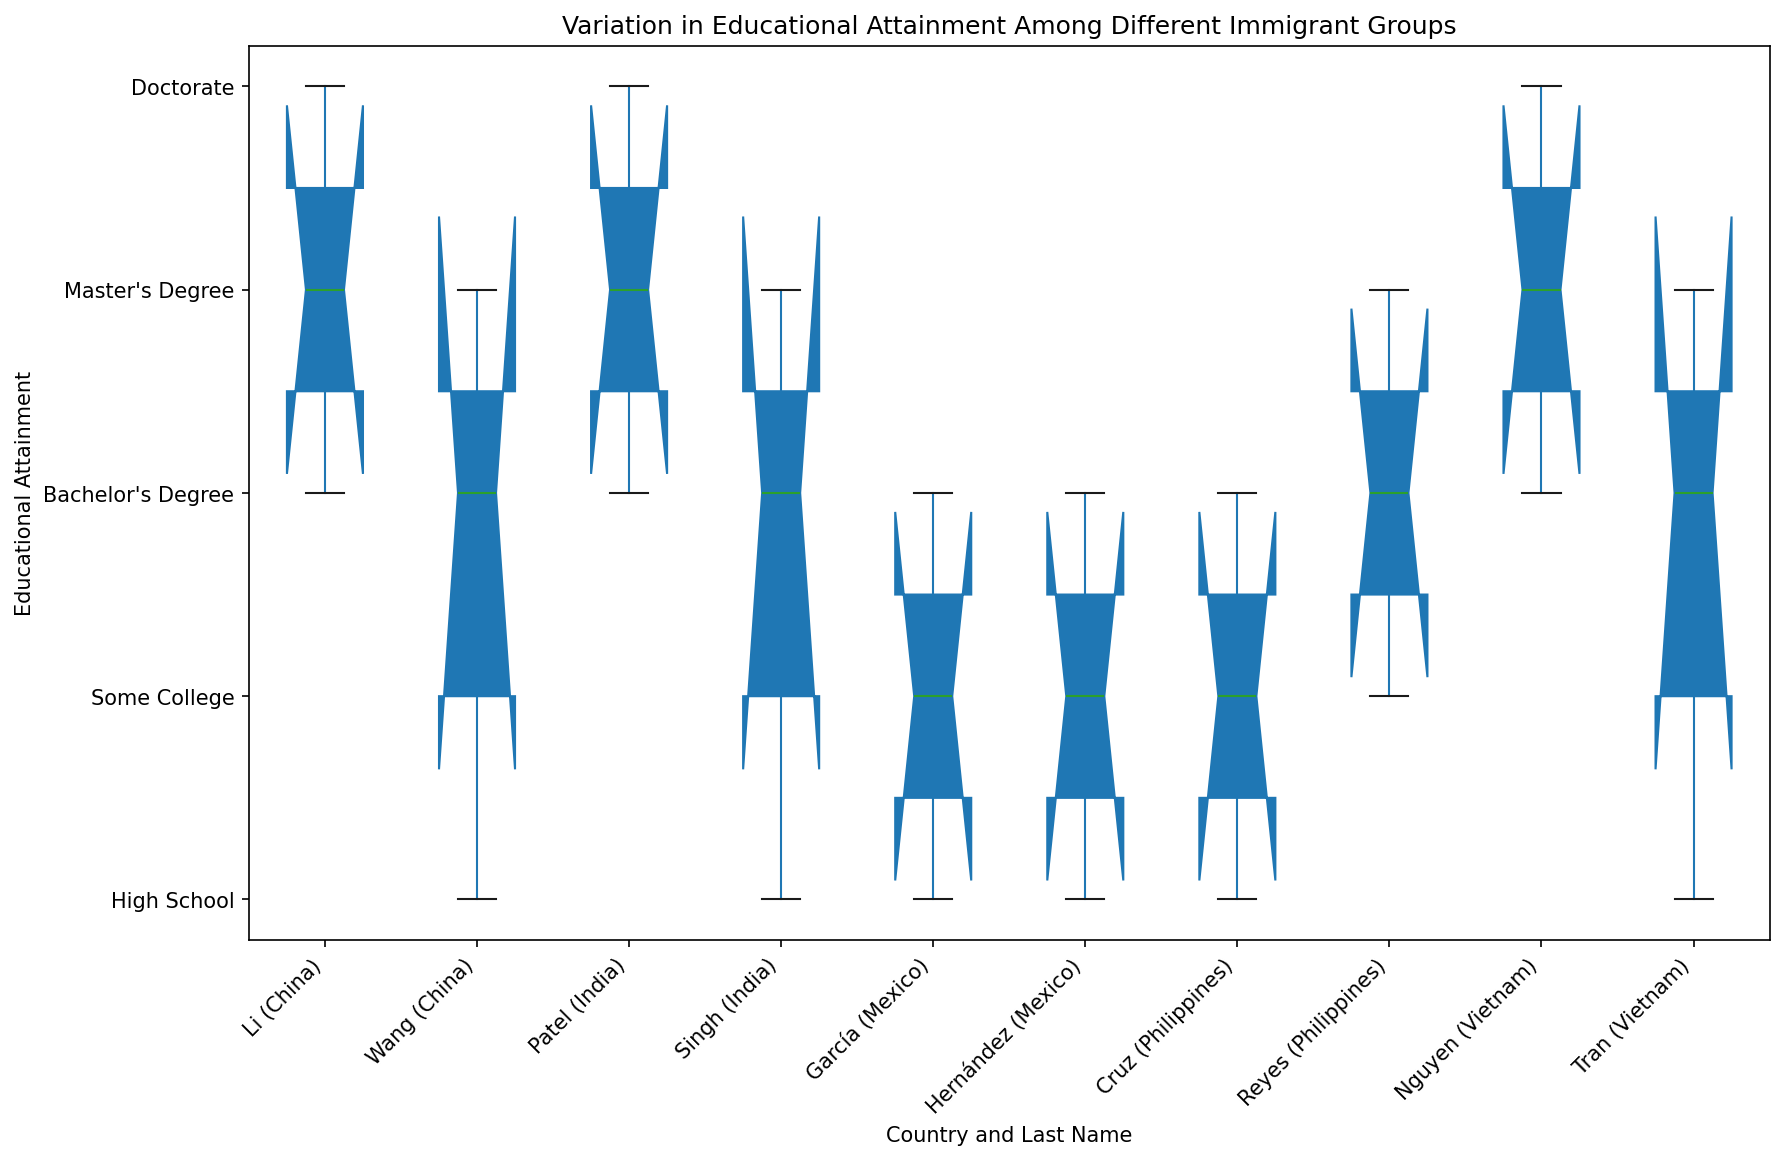Which group has the highest median educational attainment? To find which group has the highest median educational attainment, locate the central mark (median line) within each box of the plot. The Nguyen (Vietnam) group, having a median represented by the line at "Master's Degree" (3), has the highest median educational attainment.
Answer: Nguyen (Vietnam) Between the groups from India, which has greater variation in educational attainment levels: Patel or Singh? Variation can be observed by the height of the boxes and the lengths of the whiskers. The Singh group has a larger box and whiskers, stretching from "High School" to "Master's Degree" (0 to 3), compared to the Patel group that ranges from "Bachelor's Degree" to "Doctorate" (2 to 4). Therefore, the Singh group has greater variation.
Answer: Singh What is the interquartile range (IQR) of educational attainment for the Cruz group from the Philippines? IQR is the difference between the third quartile (Q3) and the first quartile (Q1). The Cruz group box ranges from "High School" to "Bachelor's Degree" (0 to 2), so the IQR is 2 - 0 = 2.
Answer: 2 How does the median educational attainment of the García group from Mexico compare to the Wang group from China? Observe the median lines within the García and Wang boxes. The García group has its median at "Some College" (1) while the Wang group has its median at "Bachelor's Degree" (2). Therefore, the García group has a lower median educational attainment than the Wang group.
Answer: Lower Which group's educational attainment is the least diverse, based on the box plot? Identify the group with the smallest range (height) of the boxes and whiskers. The Patel (India) group's range goes from "Bachelor's Degree" to "Doctorate" (2 to 4), indicating the least diversity in educational attainment as it has the least variation in the values.
Answer: Patel (India) 